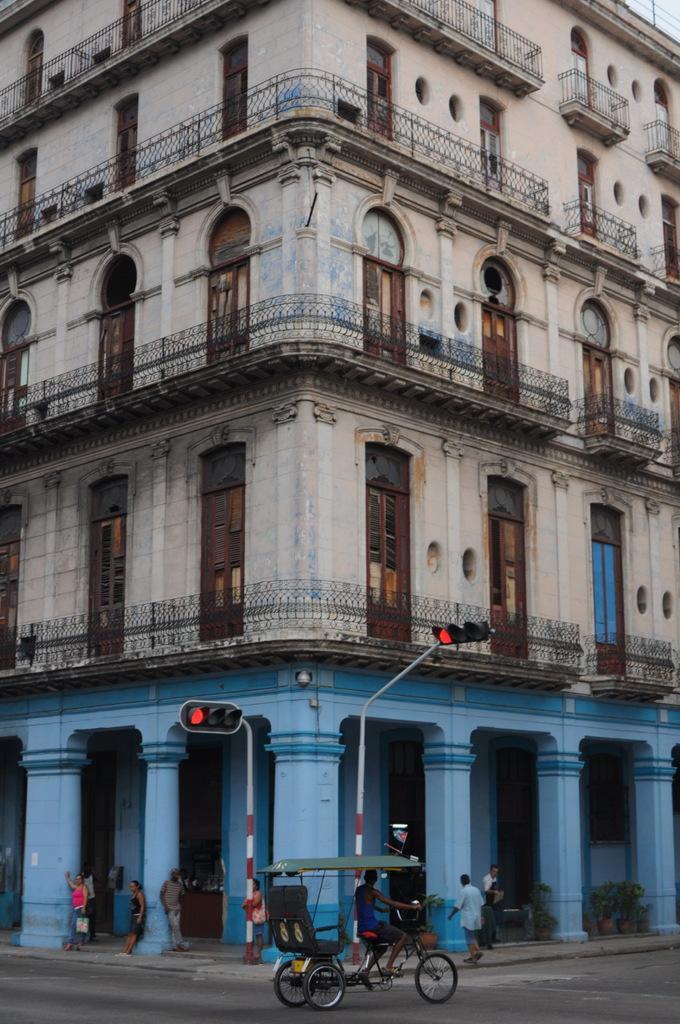Could you give a brief overview of what you see in this image? As we can see in the image there are buildings, fence, doors, windows, vehicle, few people here and there and traffic signals. 